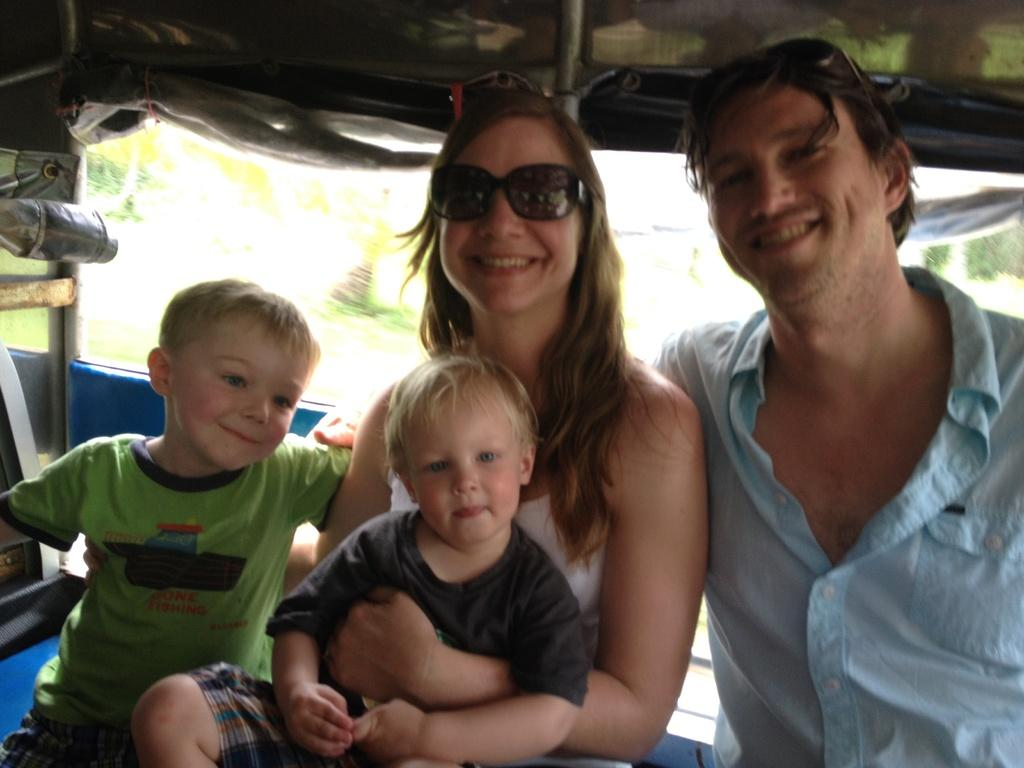How many people are present in the image? There are two persons in the image. How many children are present in the image? There are two kids in the image. What can be seen in the background of the image? There are trees in the background of the image. What is the purpose of the cover visible at the top of the image? The purpose of the cover is not specified in the facts provided. What type of slave is depicted in the image? There is no mention of a slave in the image or the provided facts. --- Facts: 1. There is a car in the image. 2. The car is red. 3. The car has four wheels. 4. There is a road in the image. 5. The road is paved. Absurd Topics: parrot, ocean, volcano Conversation: What is the main subject of the image? The main subject of the image is a car. What color is the car? The car is red. How many wheels does the car have? The car has four wheels. What type of surface is visible in the image? There is a road in the image, and it is paved. Reasoning: Let's think step by step in order to produce the conversation. We start by identifying the main subject of the image, which is the car. Then, we describe the color and number of wheels of the car. Finally, we describe the type of surface visible in the image, which is a paved road. Absurd Question/Answer: Can you see a parrot flying over the car in the image? There is no mention of a parrot in the image or the provided facts. --- Facts: 1. There is a person holding a book in the image. 2. The book has a blue cover. 3. The person is sitting on a chair. 4. There is a table in the image. 5. The table has a lamp on it. Absurd Topics: elephant, ocean, volcano Conversation: What is the person in the image holding? The person is holding a book in the image. What color is the book's cover? The book has a blue cover. What is the person sitting on? The person is sitting on a chair. What other piece of furniture is visible in the image? There is a table in the image. What is on the table? The table has a lamp on it. Reasoning: Let's think step by step in order to produce the conversation. We start by identifying the main subject of the image, which is the person holding a book. Then, we describe the color of the book's cover. Next, we mention the person's seating arrangement, which is on a chair. Finally, we describe the presence of a table and a 